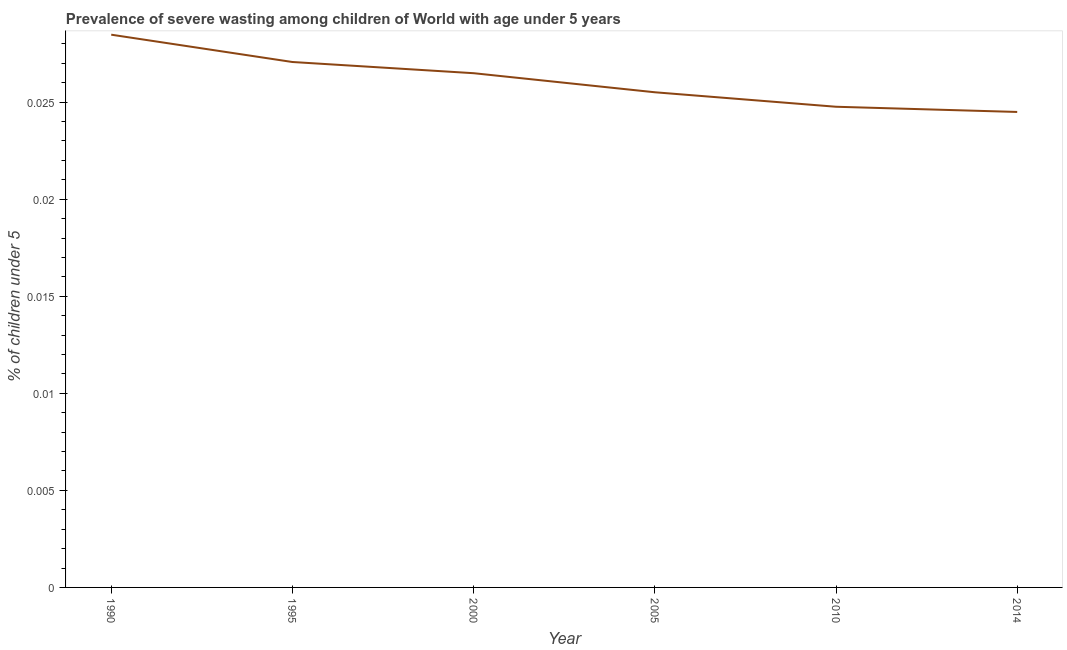What is the prevalence of severe wasting in 1995?
Provide a short and direct response. 0.03. Across all years, what is the maximum prevalence of severe wasting?
Provide a short and direct response. 0.03. Across all years, what is the minimum prevalence of severe wasting?
Provide a succinct answer. 0.02. In which year was the prevalence of severe wasting minimum?
Offer a very short reply. 2014. What is the sum of the prevalence of severe wasting?
Offer a terse response. 0.16. What is the difference between the prevalence of severe wasting in 2005 and 2010?
Provide a short and direct response. 0. What is the average prevalence of severe wasting per year?
Your answer should be compact. 0.03. What is the median prevalence of severe wasting?
Offer a very short reply. 0.03. What is the ratio of the prevalence of severe wasting in 2010 to that in 2014?
Your answer should be compact. 1.01. Is the difference between the prevalence of severe wasting in 1995 and 2000 greater than the difference between any two years?
Ensure brevity in your answer.  No. What is the difference between the highest and the second highest prevalence of severe wasting?
Your answer should be compact. 0. What is the difference between the highest and the lowest prevalence of severe wasting?
Offer a terse response. 0. Does the prevalence of severe wasting monotonically increase over the years?
Keep it short and to the point. No. What is the difference between two consecutive major ticks on the Y-axis?
Provide a succinct answer. 0.01. Does the graph contain grids?
Your response must be concise. No. What is the title of the graph?
Make the answer very short. Prevalence of severe wasting among children of World with age under 5 years. What is the label or title of the X-axis?
Offer a terse response. Year. What is the label or title of the Y-axis?
Keep it short and to the point.  % of children under 5. What is the  % of children under 5 in 1990?
Provide a short and direct response. 0.03. What is the  % of children under 5 in 1995?
Your answer should be very brief. 0.03. What is the  % of children under 5 in 2000?
Your answer should be compact. 0.03. What is the  % of children under 5 of 2005?
Provide a short and direct response. 0.03. What is the  % of children under 5 in 2010?
Keep it short and to the point. 0.02. What is the  % of children under 5 of 2014?
Your answer should be compact. 0.02. What is the difference between the  % of children under 5 in 1990 and 1995?
Keep it short and to the point. 0. What is the difference between the  % of children under 5 in 1990 and 2000?
Ensure brevity in your answer.  0. What is the difference between the  % of children under 5 in 1990 and 2005?
Provide a succinct answer. 0. What is the difference between the  % of children under 5 in 1990 and 2010?
Give a very brief answer. 0. What is the difference between the  % of children under 5 in 1990 and 2014?
Offer a terse response. 0. What is the difference between the  % of children under 5 in 1995 and 2000?
Your response must be concise. 0. What is the difference between the  % of children under 5 in 1995 and 2005?
Offer a terse response. 0. What is the difference between the  % of children under 5 in 1995 and 2010?
Provide a short and direct response. 0. What is the difference between the  % of children under 5 in 1995 and 2014?
Make the answer very short. 0. What is the difference between the  % of children under 5 in 2000 and 2005?
Give a very brief answer. 0. What is the difference between the  % of children under 5 in 2000 and 2010?
Offer a very short reply. 0. What is the difference between the  % of children under 5 in 2000 and 2014?
Give a very brief answer. 0. What is the difference between the  % of children under 5 in 2005 and 2010?
Ensure brevity in your answer.  0. What is the difference between the  % of children under 5 in 2005 and 2014?
Provide a succinct answer. 0. What is the difference between the  % of children under 5 in 2010 and 2014?
Your answer should be compact. 0. What is the ratio of the  % of children under 5 in 1990 to that in 1995?
Offer a terse response. 1.05. What is the ratio of the  % of children under 5 in 1990 to that in 2000?
Keep it short and to the point. 1.07. What is the ratio of the  % of children under 5 in 1990 to that in 2005?
Your response must be concise. 1.12. What is the ratio of the  % of children under 5 in 1990 to that in 2010?
Offer a very short reply. 1.15. What is the ratio of the  % of children under 5 in 1990 to that in 2014?
Offer a very short reply. 1.16. What is the ratio of the  % of children under 5 in 1995 to that in 2005?
Make the answer very short. 1.06. What is the ratio of the  % of children under 5 in 1995 to that in 2010?
Make the answer very short. 1.09. What is the ratio of the  % of children under 5 in 1995 to that in 2014?
Your response must be concise. 1.1. What is the ratio of the  % of children under 5 in 2000 to that in 2005?
Make the answer very short. 1.04. What is the ratio of the  % of children under 5 in 2000 to that in 2010?
Provide a succinct answer. 1.07. What is the ratio of the  % of children under 5 in 2000 to that in 2014?
Give a very brief answer. 1.08. What is the ratio of the  % of children under 5 in 2005 to that in 2014?
Offer a very short reply. 1.04. What is the ratio of the  % of children under 5 in 2010 to that in 2014?
Your response must be concise. 1.01. 